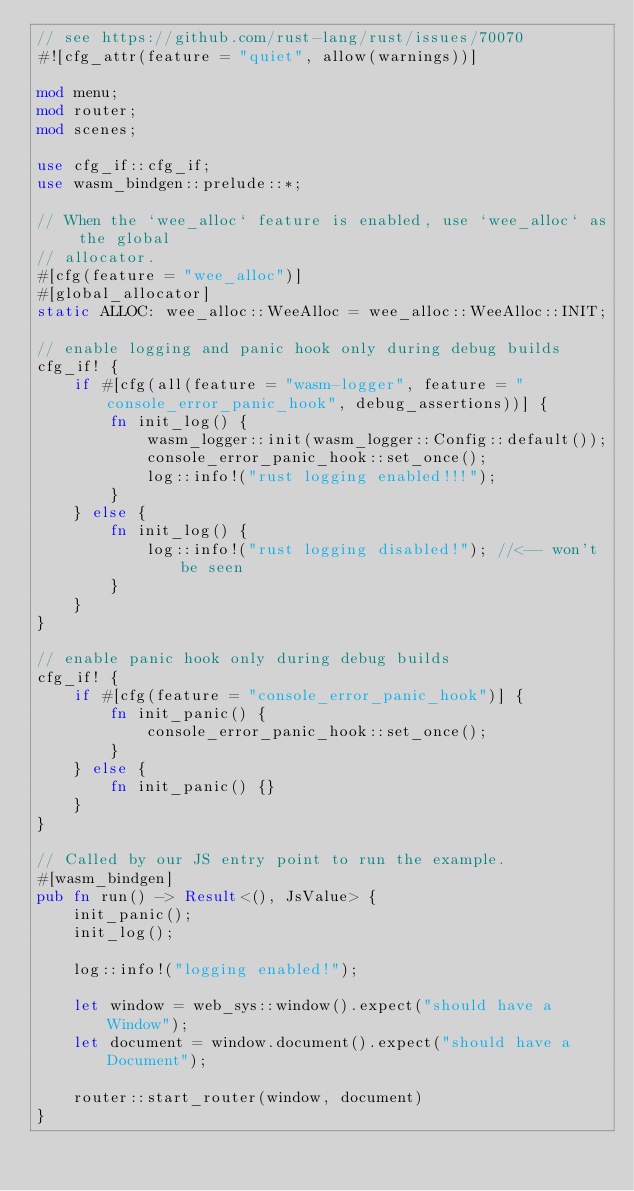Convert code to text. <code><loc_0><loc_0><loc_500><loc_500><_Rust_>// see https://github.com/rust-lang/rust/issues/70070
#![cfg_attr(feature = "quiet", allow(warnings))]

mod menu;
mod router;
mod scenes;

use cfg_if::cfg_if;
use wasm_bindgen::prelude::*;

// When the `wee_alloc` feature is enabled, use `wee_alloc` as the global
// allocator.
#[cfg(feature = "wee_alloc")]
#[global_allocator]
static ALLOC: wee_alloc::WeeAlloc = wee_alloc::WeeAlloc::INIT;

// enable logging and panic hook only during debug builds
cfg_if! {
    if #[cfg(all(feature = "wasm-logger", feature = "console_error_panic_hook", debug_assertions))] {
        fn init_log() {
            wasm_logger::init(wasm_logger::Config::default());
            console_error_panic_hook::set_once();
            log::info!("rust logging enabled!!!");
        }
    } else {
        fn init_log() {
            log::info!("rust logging disabled!"); //<-- won't be seen
        }
    }
}

// enable panic hook only during debug builds
cfg_if! {
    if #[cfg(feature = "console_error_panic_hook")] {
        fn init_panic() {
            console_error_panic_hook::set_once();
        }
    } else {
        fn init_panic() {}
    }
}

// Called by our JS entry point to run the example.
#[wasm_bindgen]
pub fn run() -> Result<(), JsValue> {
    init_panic();
    init_log();

    log::info!("logging enabled!");

    let window = web_sys::window().expect("should have a Window");
    let document = window.document().expect("should have a Document");

    router::start_router(window, document)
}
</code> 